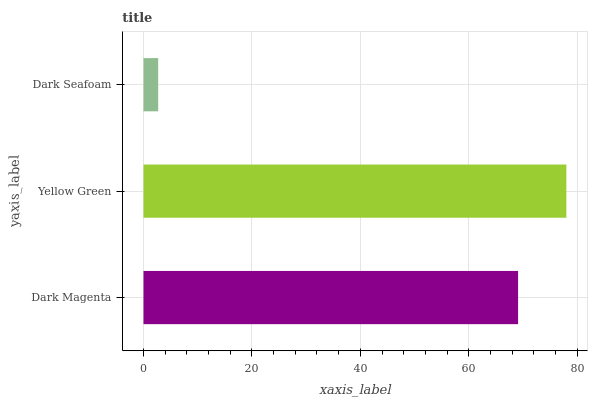Is Dark Seafoam the minimum?
Answer yes or no. Yes. Is Yellow Green the maximum?
Answer yes or no. Yes. Is Yellow Green the minimum?
Answer yes or no. No. Is Dark Seafoam the maximum?
Answer yes or no. No. Is Yellow Green greater than Dark Seafoam?
Answer yes or no. Yes. Is Dark Seafoam less than Yellow Green?
Answer yes or no. Yes. Is Dark Seafoam greater than Yellow Green?
Answer yes or no. No. Is Yellow Green less than Dark Seafoam?
Answer yes or no. No. Is Dark Magenta the high median?
Answer yes or no. Yes. Is Dark Magenta the low median?
Answer yes or no. Yes. Is Yellow Green the high median?
Answer yes or no. No. Is Dark Seafoam the low median?
Answer yes or no. No. 